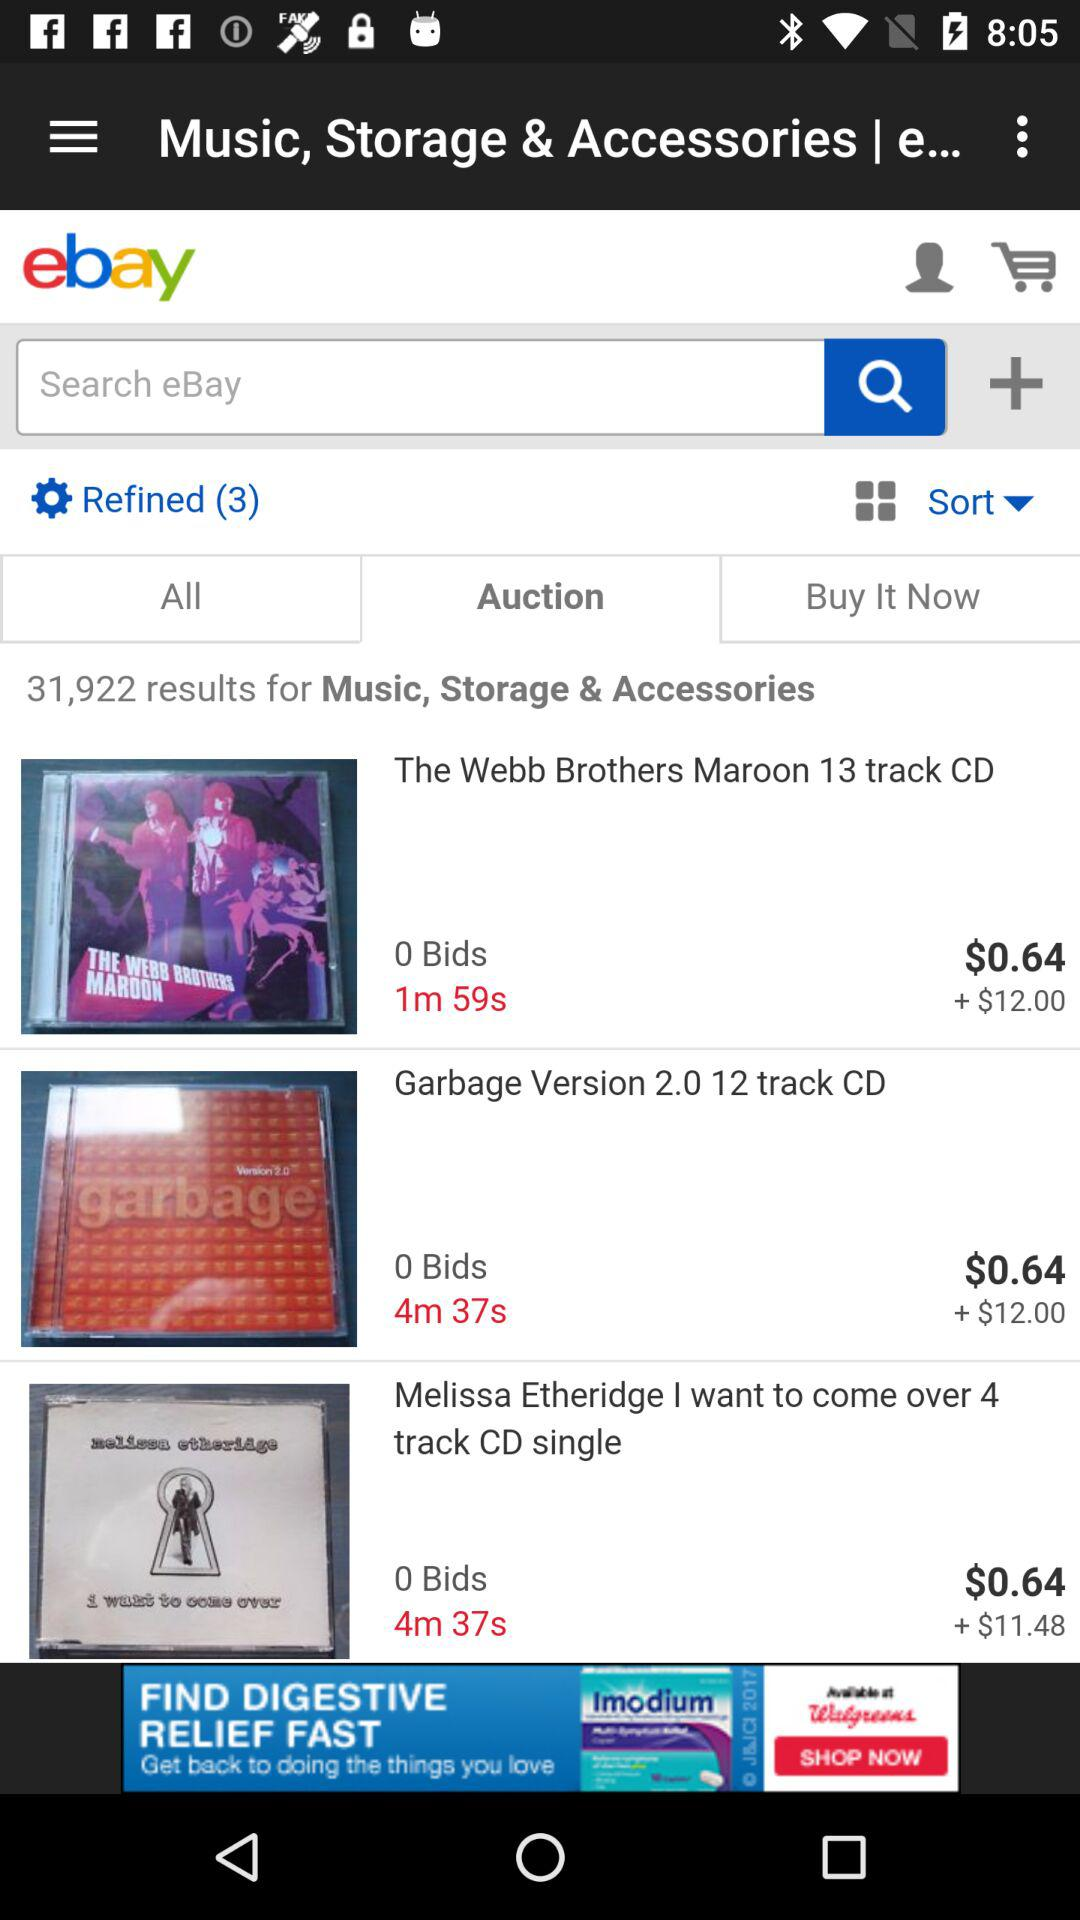What is the cost of "Melissa Etheridge I want to come over 4 track CD single"? The cost of "Melissa Etheridge I want to come over 4 track CD single" is $0.64. 